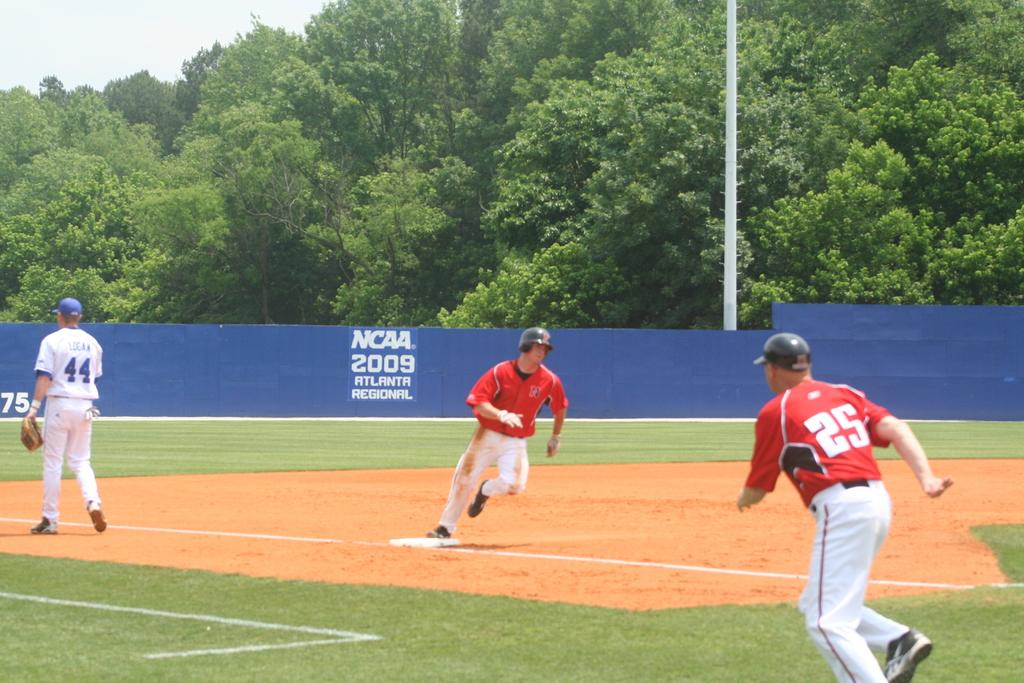<image>
Provide a brief description of the given image. Baseball player wearing number 44 walking on the field. 